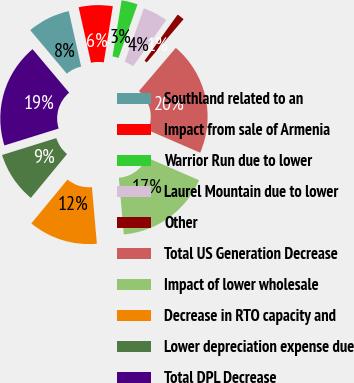Convert chart to OTSL. <chart><loc_0><loc_0><loc_500><loc_500><pie_chart><fcel>Southland related to an<fcel>Impact from sale of Armenia<fcel>Warrior Run due to lower<fcel>Laurel Mountain due to lower<fcel>Other<fcel>Total US Generation Decrease<fcel>Impact of lower wholesale<fcel>Decrease in RTO capacity and<fcel>Lower depreciation expense due<fcel>Total DPL Decrease<nl><fcel>7.63%<fcel>6.05%<fcel>2.89%<fcel>4.47%<fcel>1.32%<fcel>20.26%<fcel>17.11%<fcel>12.37%<fcel>9.21%<fcel>18.68%<nl></chart> 